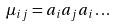<formula> <loc_0><loc_0><loc_500><loc_500>\mu _ { i j } = a _ { i } a _ { j } a _ { i } \dots</formula> 